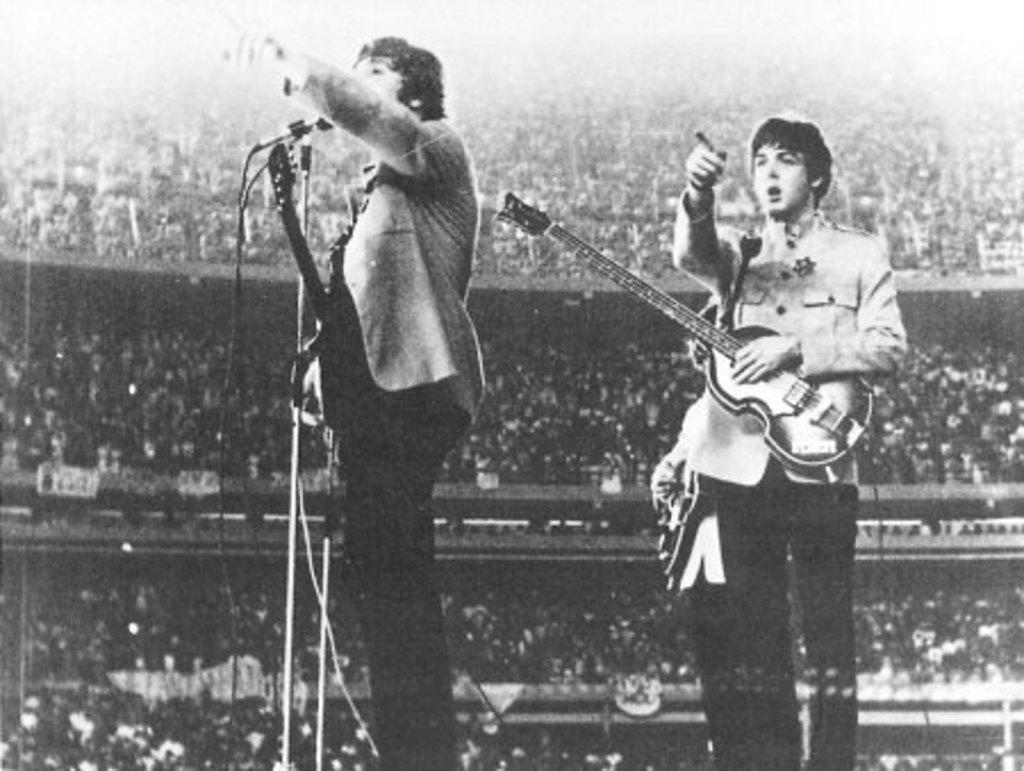Could you give a brief overview of what you see in this image? Two persons standing wearing guitar,this is microphone and this is crowd. 